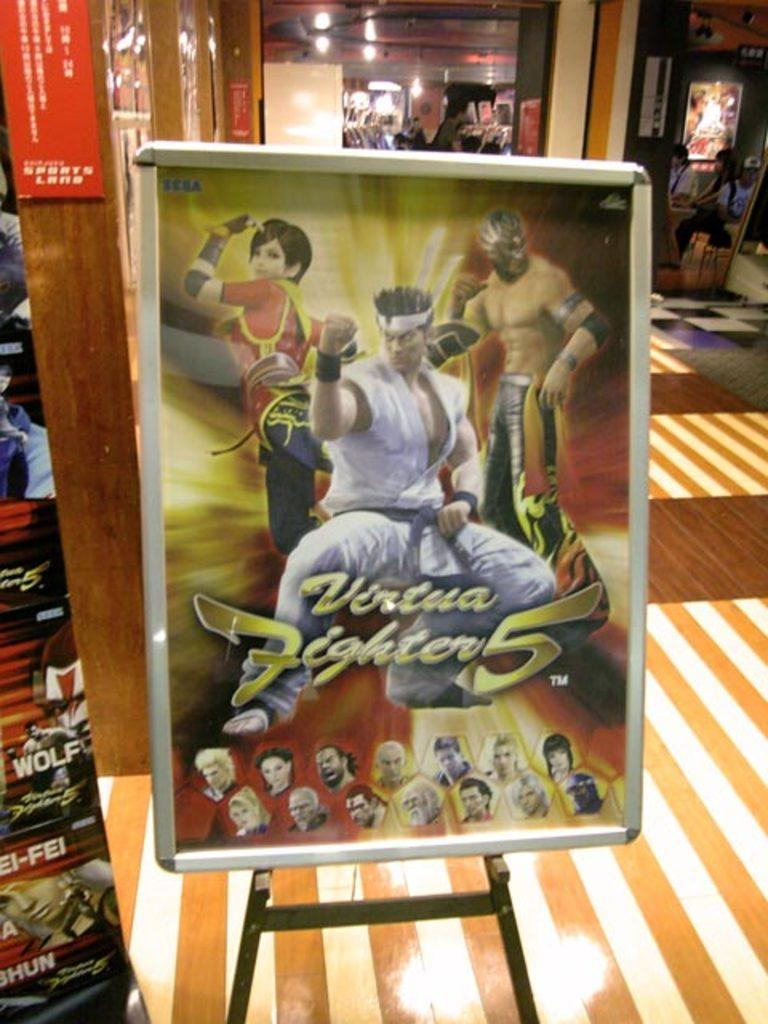Provide a one-sentence caption for the provided image. A poster for Virtua Fighter 5 in a room with stripey carpet. 